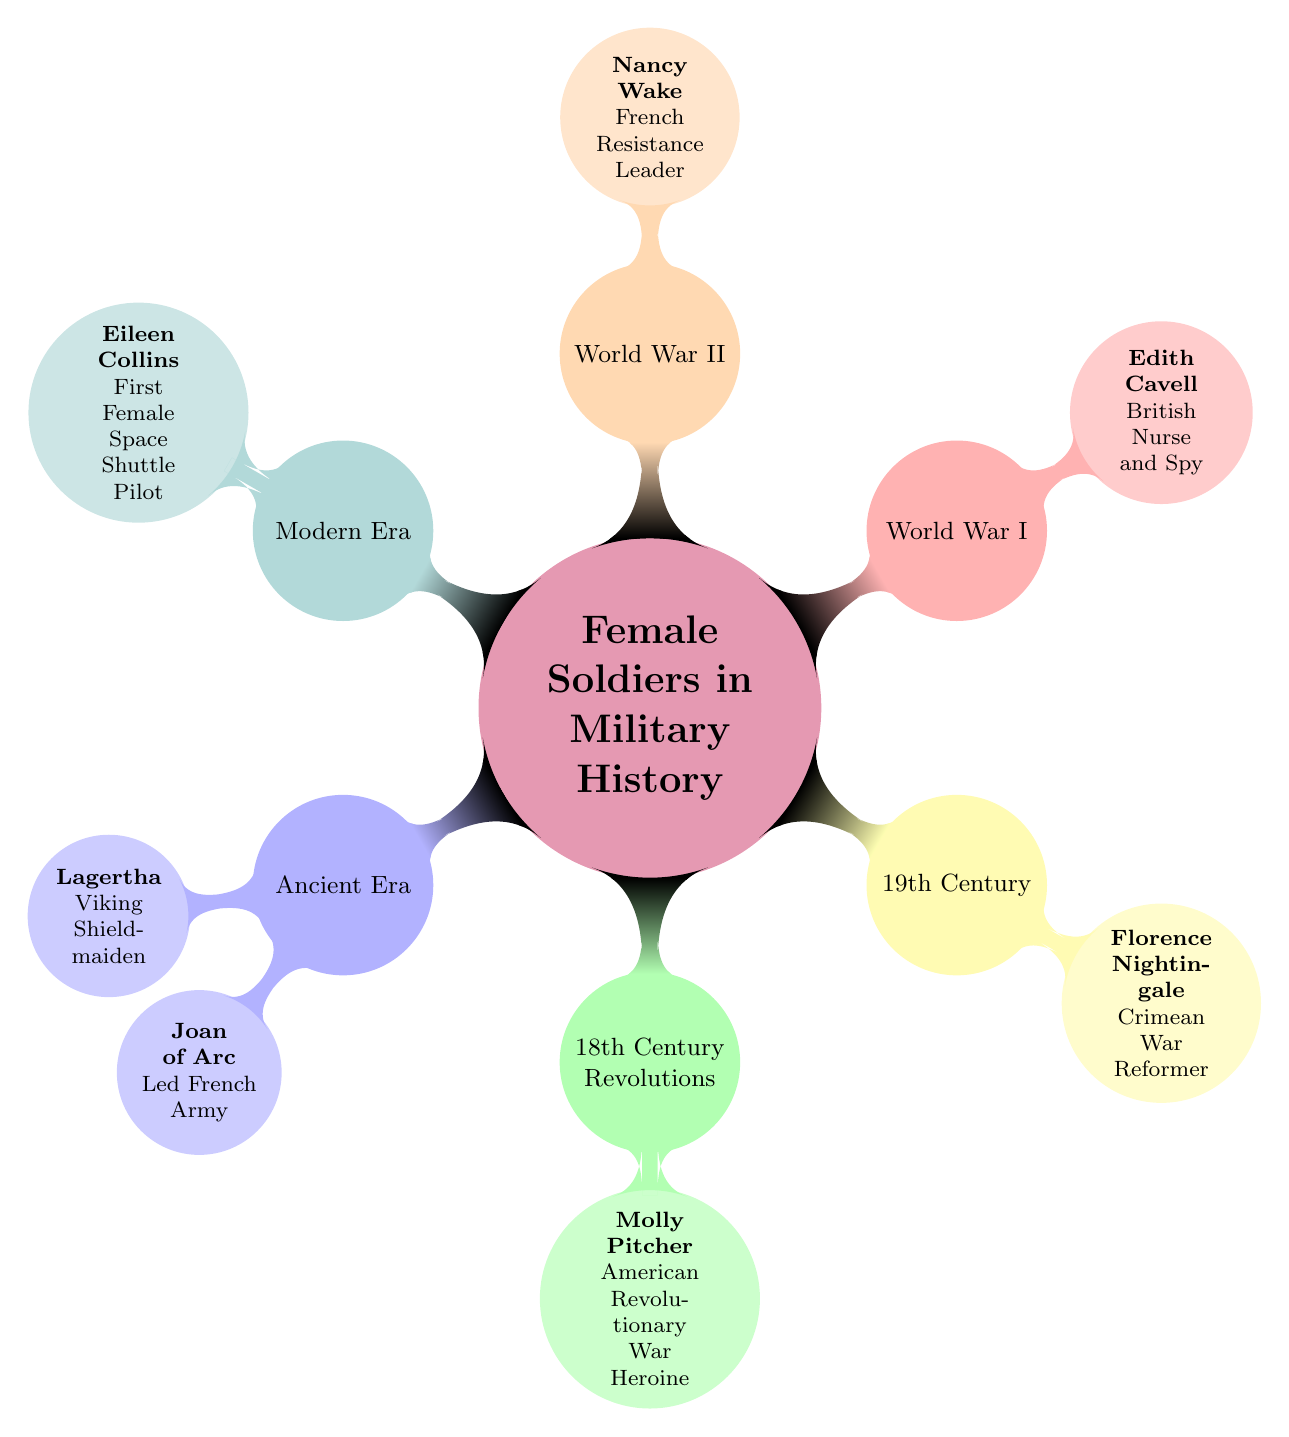What is the earliest era represented in the diagram? The diagram includes specific categories representing periods in military history. The first child node under the main concept "Female Soldiers in Military History" indicates "Ancient Era" as the earliest term listed.
Answer: Ancient Era How many notable female figures are listed in the "World War II" section? The section titled "World War II" contains one notable female figure, which is "Nancy Wake." Therefore, the count is taken from the single entry under that category.
Answer: 1 Which notable figure is associated with the "19th Century" section? In the "19th Century" category, the diagram specifies "Florence Nightingale" as the significant figure, which can be found as a child node under that heading.
Answer: Florence Nightingale Who is the notable figure associated with the "Modern Era"? The "Modern Era" section lists "Eileen Collins" as its notable figure, this can be directly identified from the child node corresponding to that category.
Answer: Eileen Collins How many total sections are presented in the timeline? The diagram has six main sections, each representing a different era or conflict, indicated as child nodes branching from the central theme of "Female Soldiers in Military History."
Answer: 6 Which notable figure is linked to espionage during World War I? Under the "World War I" category, "Edith Cavell," identified as a British Nurse and Spy, is the figure associated with espionage, as stated in the descriptive node.
Answer: Edith Cavell What contribution is "Molly Pitcher" known for? The diagram places "Molly Pitcher" under the "18th Century Revolutions" category, where she is described as an "American Revolutionary War Heroine," highlighting her military contribution during that period.
Answer: American Revolutionary War Heroine Which section features a figure known for leading an army? The figure "Joan of Arc," documented under the "Ancient Era," is recognized for her role in leading the French army, which is confirmed directly by the child node label in that category.
Answer: Led French Army 